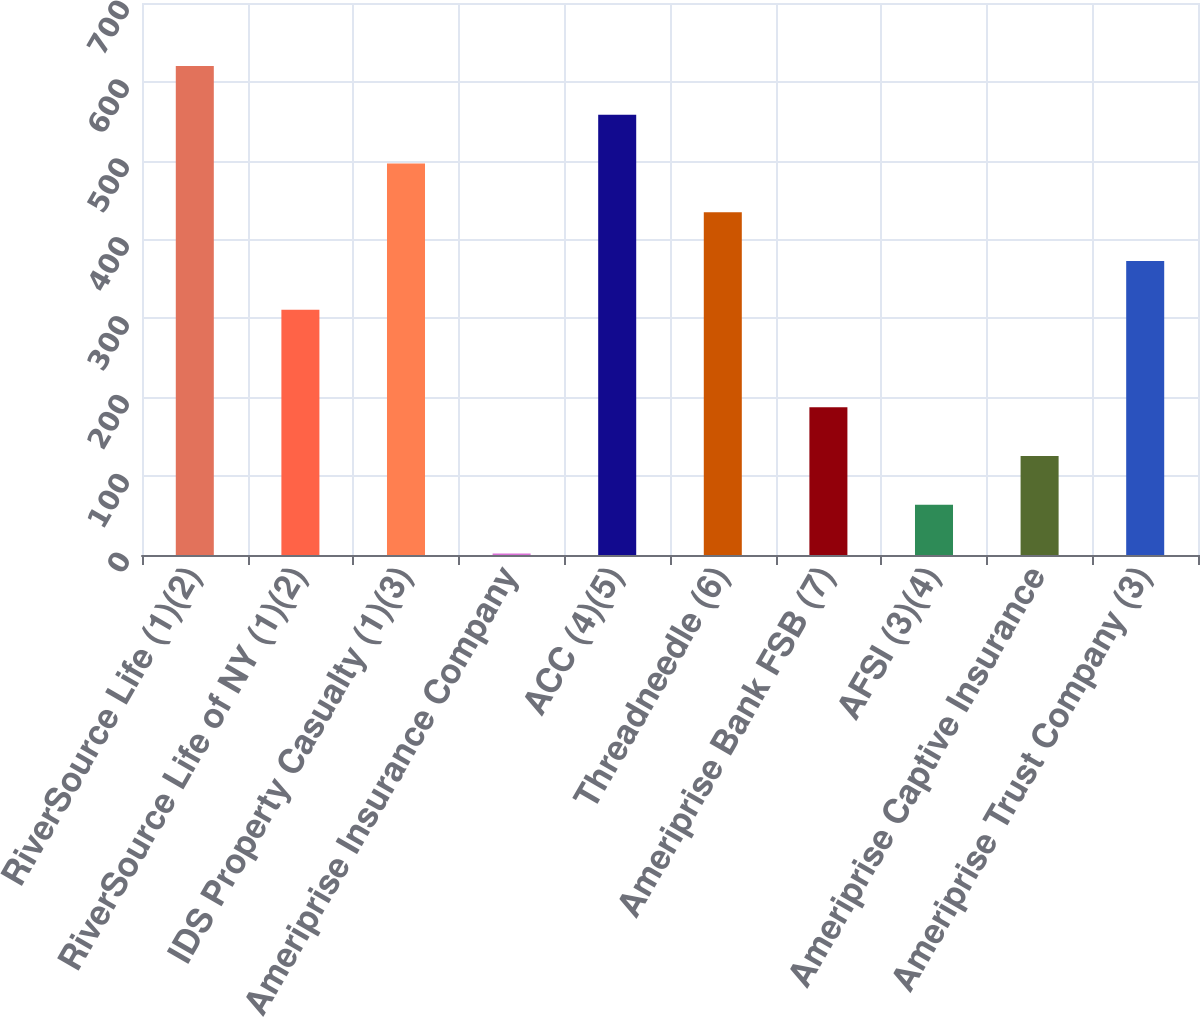<chart> <loc_0><loc_0><loc_500><loc_500><bar_chart><fcel>RiverSource Life (1)(2)<fcel>RiverSource Life of NY (1)(2)<fcel>IDS Property Casualty (1)(3)<fcel>Ameriprise Insurance Company<fcel>ACC (4)(5)<fcel>Threadneedle (6)<fcel>Ameriprise Bank FSB (7)<fcel>AFSI (3)(4)<fcel>Ameriprise Captive Insurance<fcel>Ameriprise Trust Company (3)<nl><fcel>620<fcel>311<fcel>496.4<fcel>2<fcel>558.2<fcel>434.6<fcel>187.4<fcel>63.8<fcel>125.6<fcel>372.8<nl></chart> 